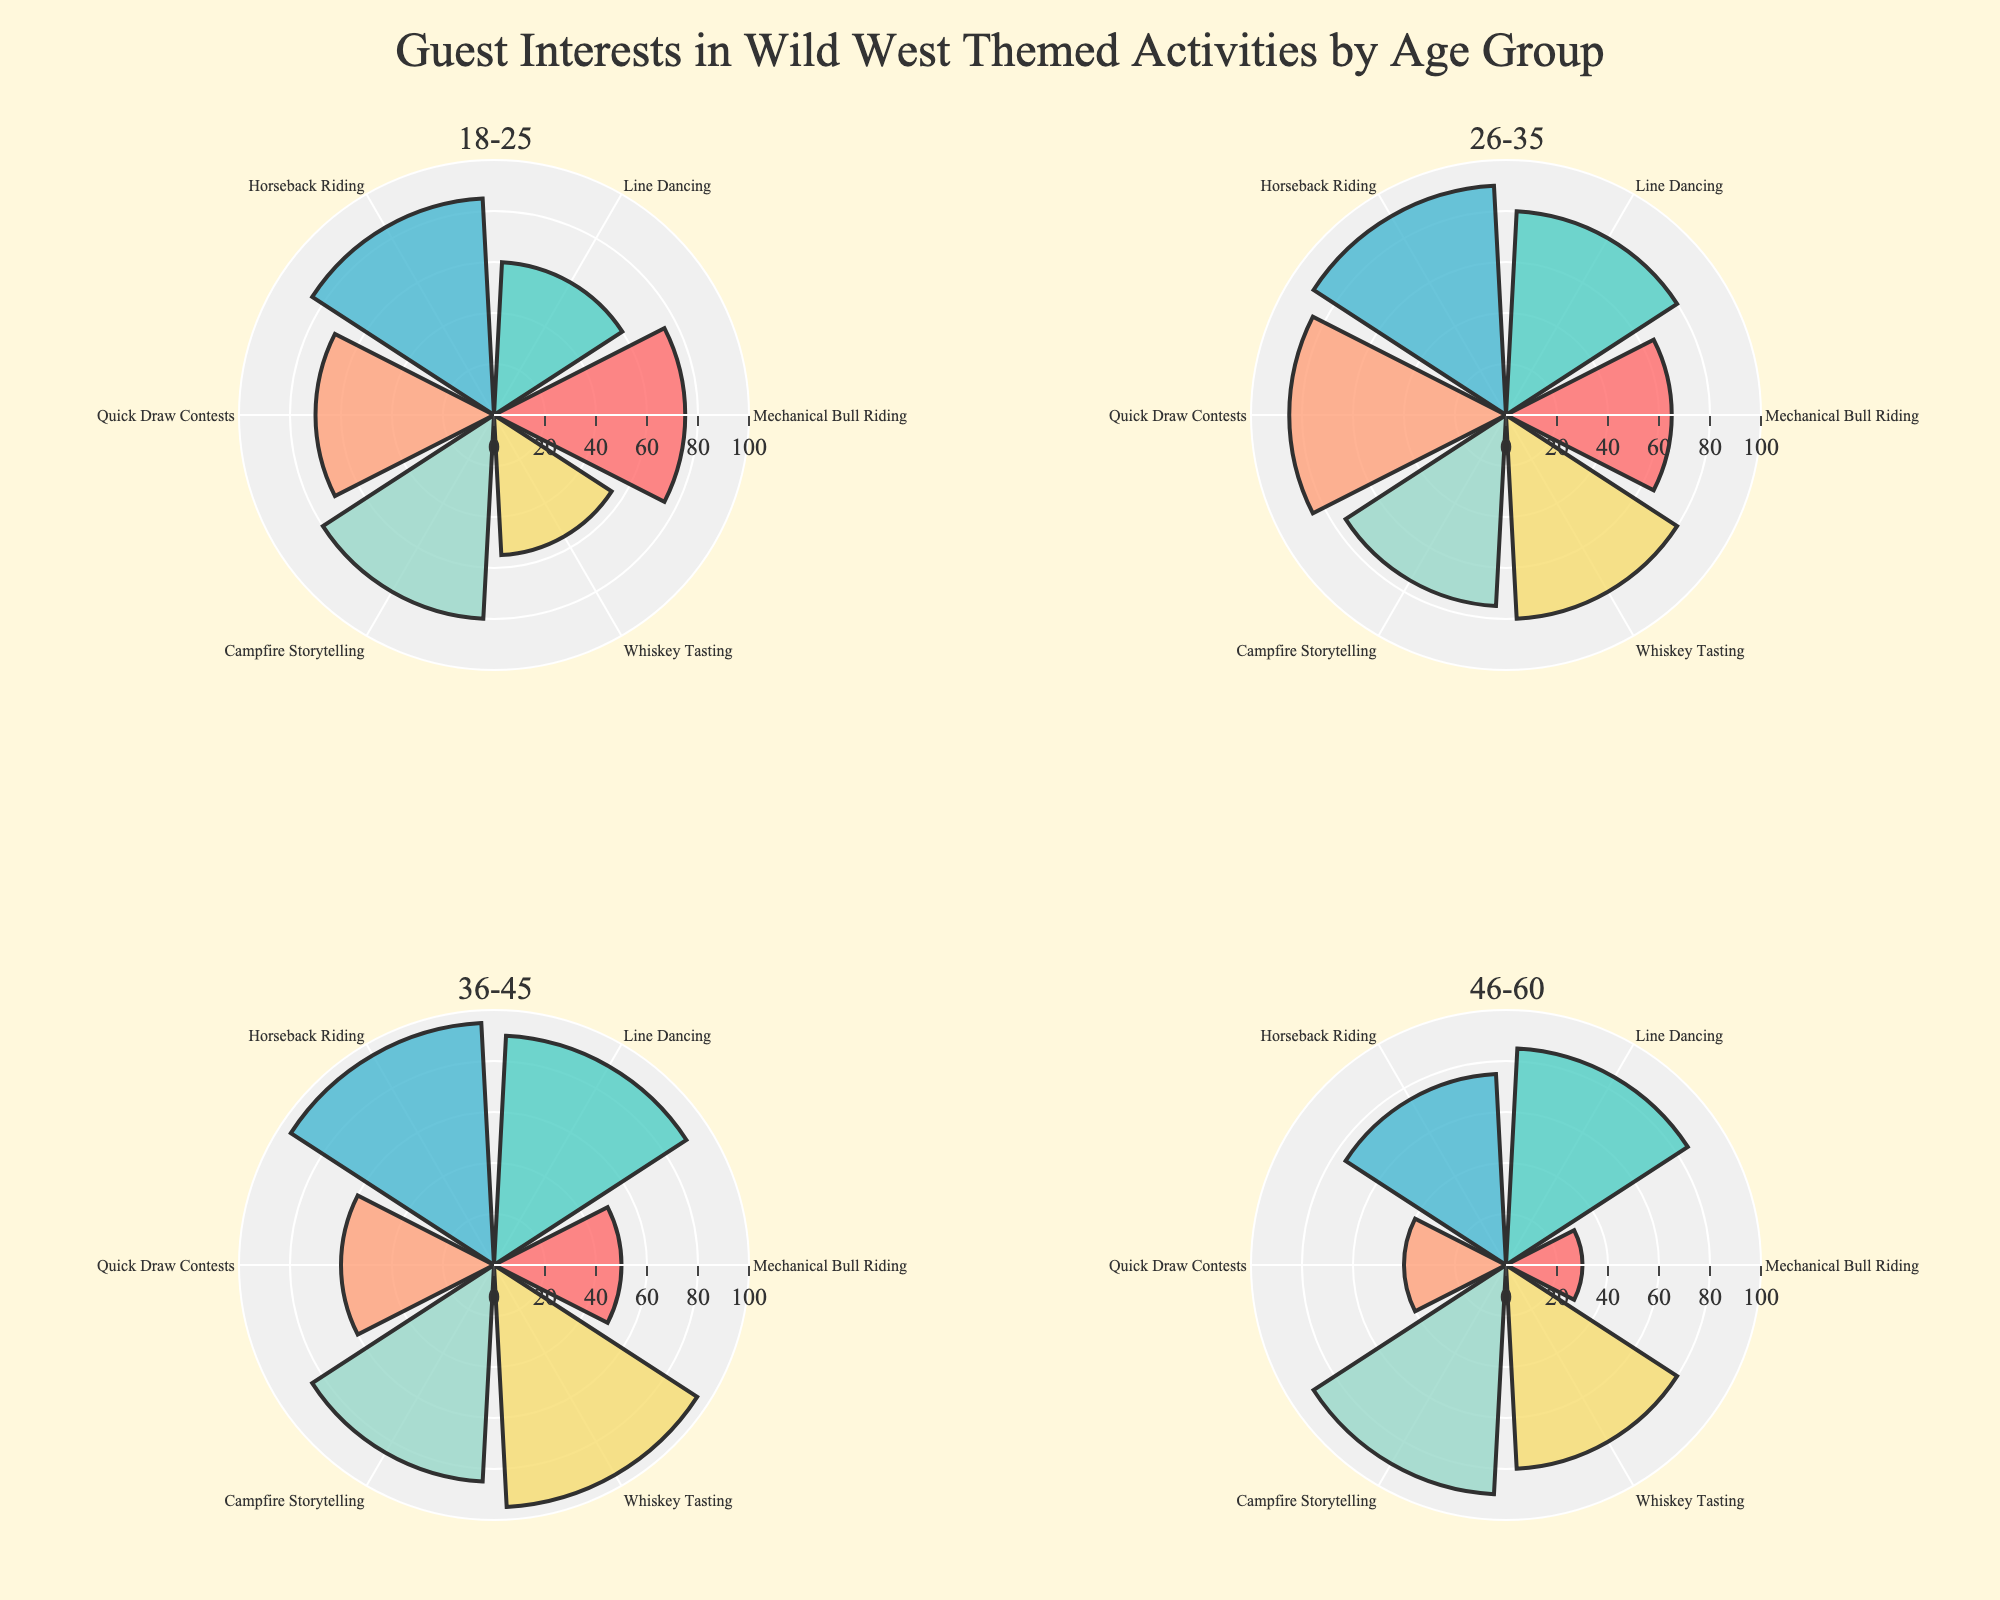Which age group has the highest interest level in Horseback Riding? In the subplot for each age group, we observe the "Horseback Riding" segment. The age group 36-45 shows the highest bar, indicating the highest interest level.
Answer: 36-45 What is the average interest level in Line Dancing across all age groups? Sum the interest levels for Line Dancing across age groups: 60 (18-25) + 80 (26-35) + 90 (36-45) + 85 (46-60). The total is 315. Divide by the number of age groups, which is 4. So, 315 / 4 = 78.75.
Answer: 78.75 Which activity has the lowest interest level for the 46-60 age group? In the subplot for the 46-60 age group, identify the smallest bar. The Mechanical Bull Riding bar is the smallest.
Answer: Mechanical Bull Riding Compare the interest level in Whiskey Tasting for ages 26-35 and 36-45. Which age group shows a higher interest? Observe the Whiskey Tasting bars for the 26-35 age group (80) and the 36-45 age group (95). The 36-45 age group has a higher interest level.
Answer: 36-45 What is the sum of interest levels for Campfire Storytelling across all age groups? Add the interest levels for Campfire Storytelling: 80 (18-25) + 75 (26-35) + 85 (36-45) + 90 (46-60). The total is 330.
Answer: 330 Which activity shows the most consistent interest level across all age groups? Evaluate the bars for each activity across all age groups. Horseback Riding and Campfire Storytelling have relatively high and consistent levels, but Horseback Riding has consistently high levels (85, 90, 95, 75).
Answer: Horseback Riding Which age group's interest level distribution has the highest peak? Identify the subplot with the tallest bar. The 36-45 age group has a peak of 95 in both Horseback Riding and Whiskey Tasting.
Answer: 36-45 Is the interest level in Quick Draw Contests higher for 18-25 or 26-35 age group? Compare the heights of the bars for Quick Draw Contests for 18-25 (70) and 26-35 (85). The 26-35 age group has a higher interest level.
Answer: 26-35 What is the observed relationship between the interest levels in Mechanical Bull Riding and the age group? As age increases, the interest level in Mechanical Bull Riding decreases: 75 (18-25), 65 (26-35), 50 (36-45), and 30 (46-60). The trend shows a negative correlation between age and interest level.
Answer: Decreasing trend Which age group shows the least variation in interest levels across different activities? Analyze the range of interest levels (difference between the highest and lowest values) for each age group. The 46-60 age group has the smallest variation (90-30=60).
Answer: 46-60 